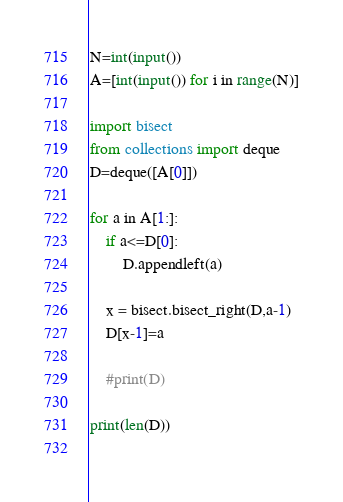Convert code to text. <code><loc_0><loc_0><loc_500><loc_500><_Python_>N=int(input())
A=[int(input()) for i in range(N)]

import bisect
from collections import deque
D=deque([A[0]])

for a in A[1:]:
    if a<=D[0]:
        D.appendleft(a)
        
    x = bisect.bisect_right(D,a-1)
    D[x-1]=a

    #print(D)

print(len(D))
    </code> 